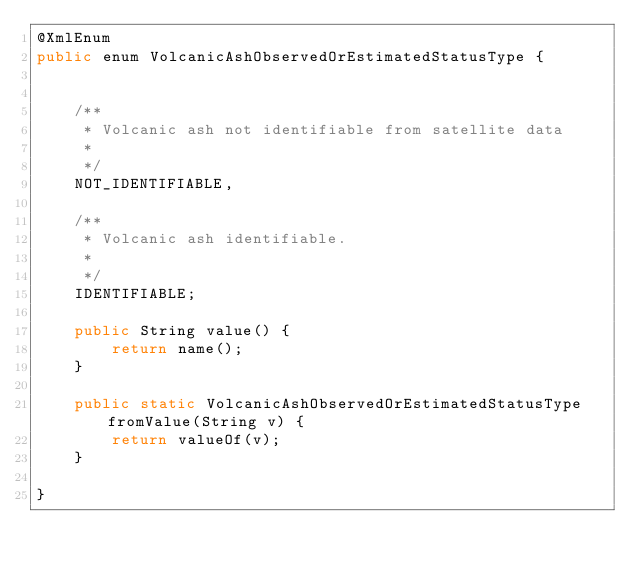<code> <loc_0><loc_0><loc_500><loc_500><_Java_>@XmlEnum
public enum VolcanicAshObservedOrEstimatedStatusType {


    /**
     * Volcanic ash not identifiable from satellite data
     * 
     */
    NOT_IDENTIFIABLE,

    /**
     * Volcanic ash identifiable.
     * 
     */
    IDENTIFIABLE;

    public String value() {
        return name();
    }

    public static VolcanicAshObservedOrEstimatedStatusType fromValue(String v) {
        return valueOf(v);
    }

}
</code> 